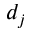Convert formula to latex. <formula><loc_0><loc_0><loc_500><loc_500>d _ { j }</formula> 